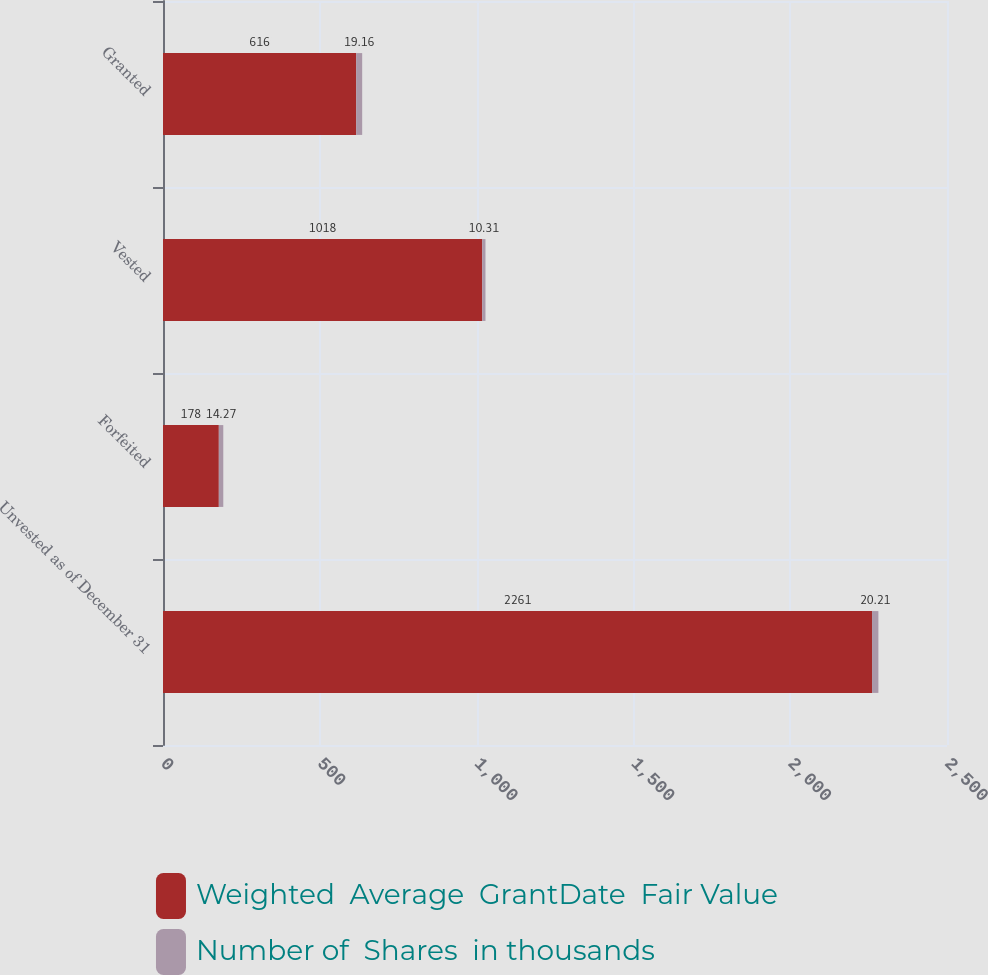Convert chart. <chart><loc_0><loc_0><loc_500><loc_500><stacked_bar_chart><ecel><fcel>Unvested as of December 31<fcel>Forfeited<fcel>Vested<fcel>Granted<nl><fcel>Weighted  Average  GrantDate  Fair Value<fcel>2261<fcel>178<fcel>1018<fcel>616<nl><fcel>Number of  Shares  in thousands<fcel>20.21<fcel>14.27<fcel>10.31<fcel>19.16<nl></chart> 